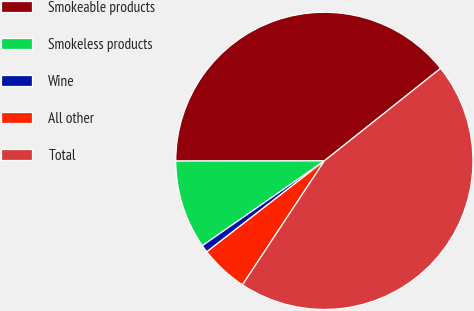Convert chart. <chart><loc_0><loc_0><loc_500><loc_500><pie_chart><fcel>Smokeable products<fcel>Smokeless products<fcel>Wine<fcel>All other<fcel>Total<nl><fcel>39.32%<fcel>9.65%<fcel>0.81%<fcel>5.23%<fcel>44.99%<nl></chart> 